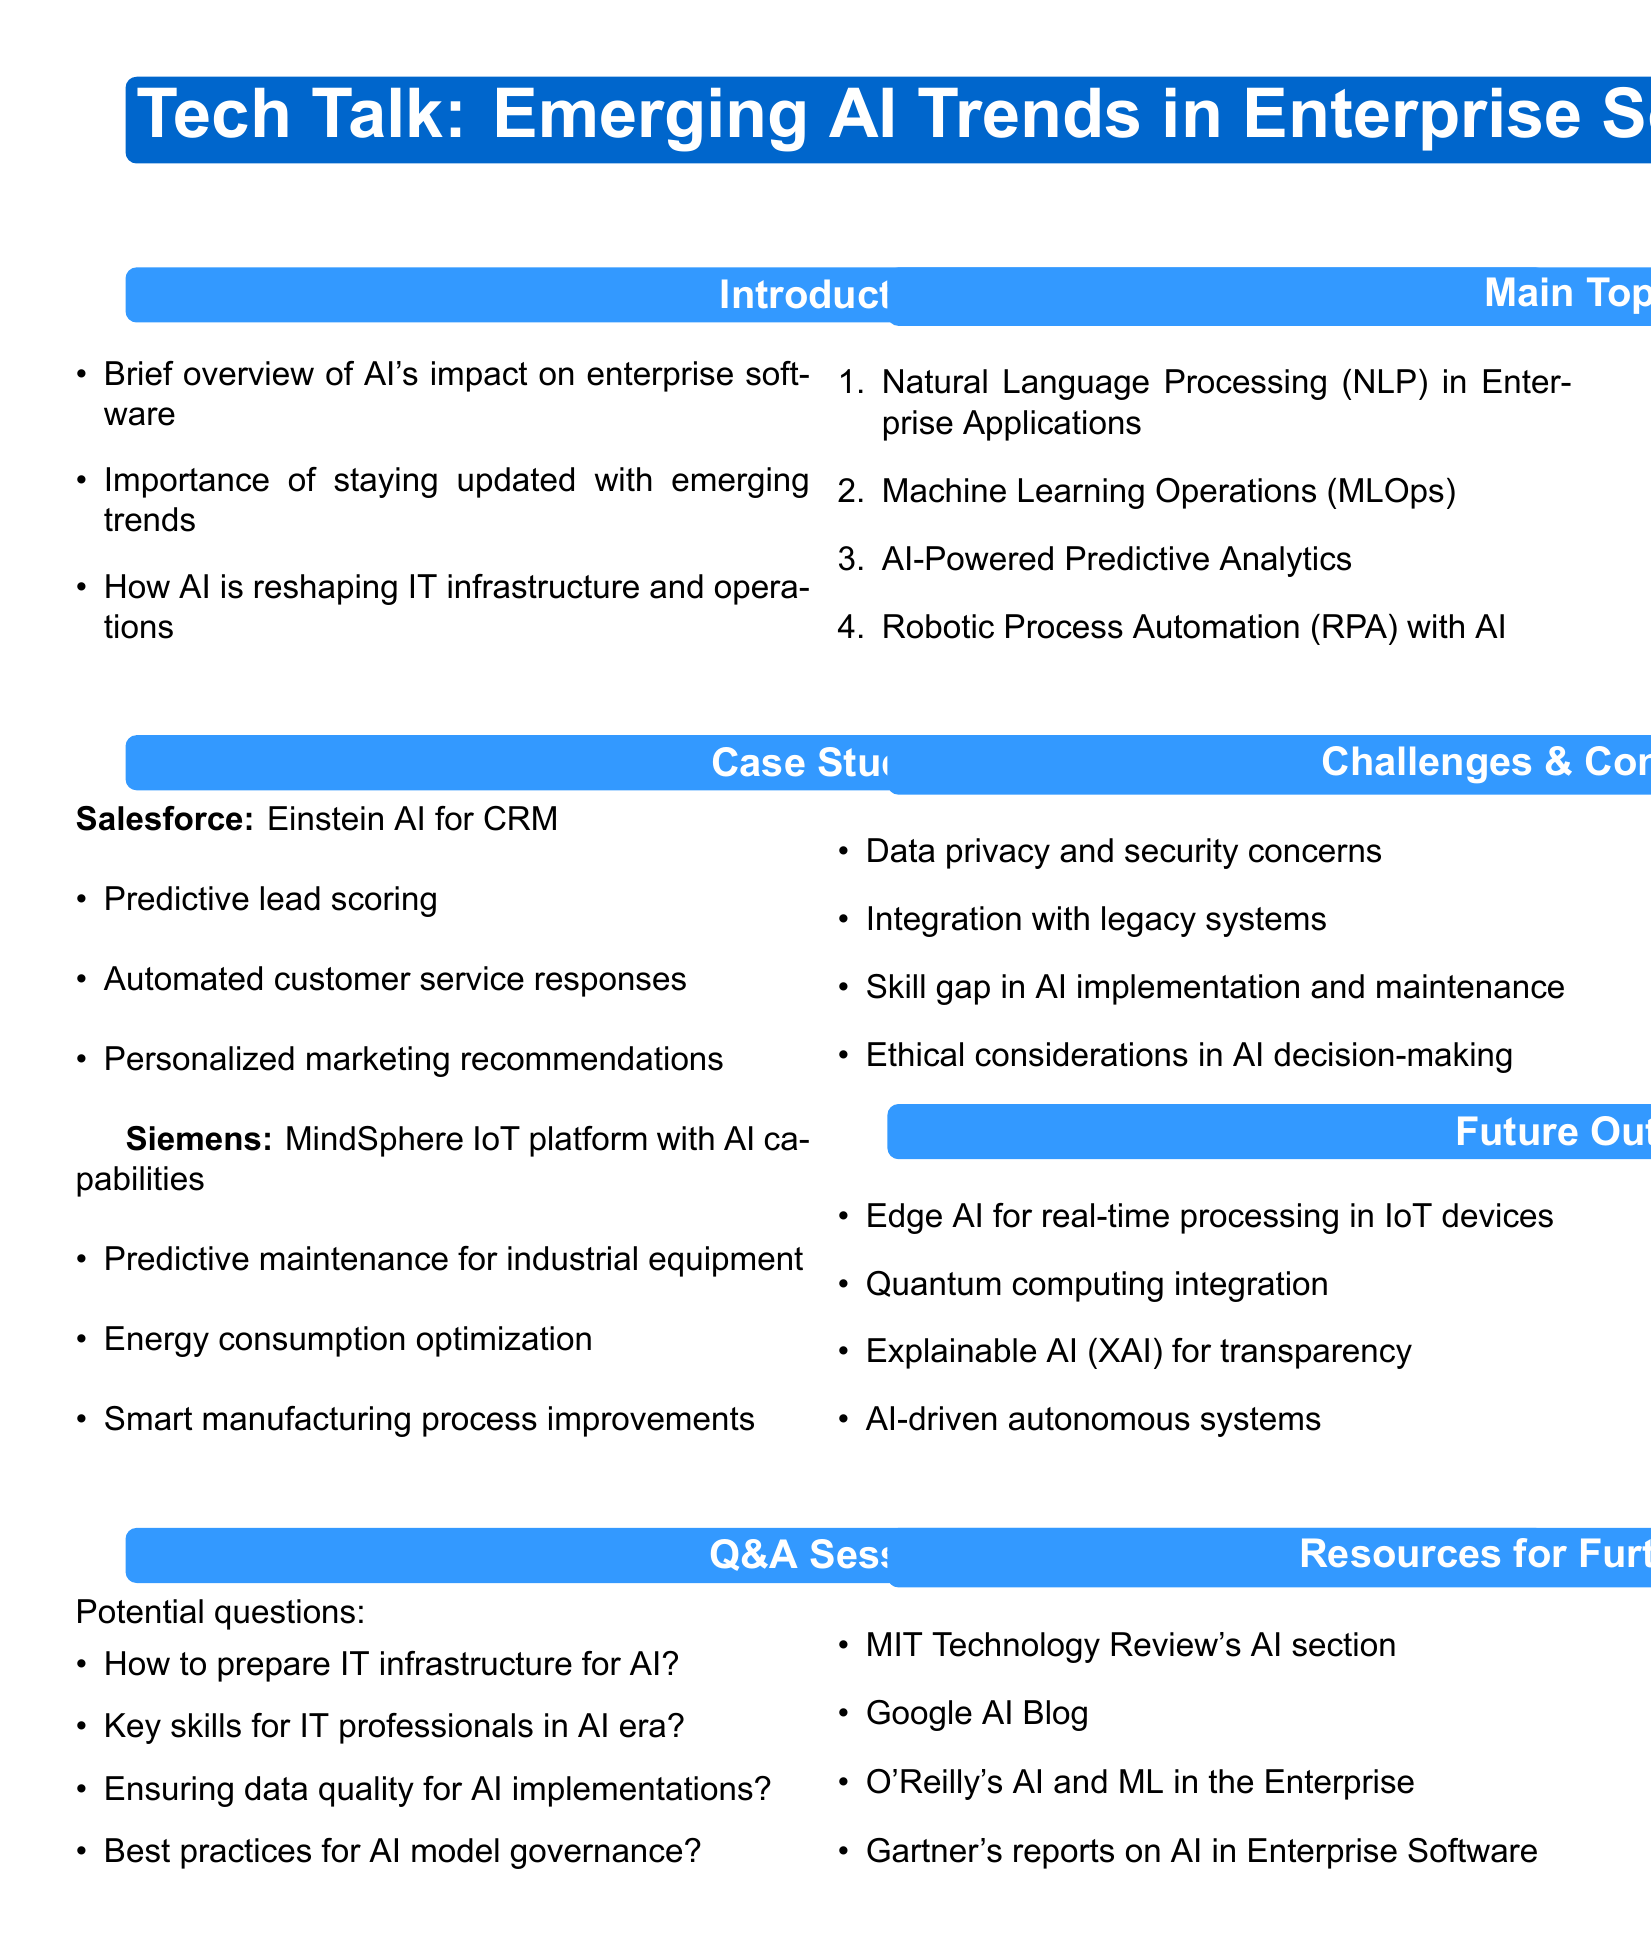What is the title of the tech talk? The title of the tech talk is stated at the beginning of the document.
Answer: Tech Talk: Emerging AI Trends in Enterprise Software What is one benefit of Salesforce's AI implementation? The document lists multiple benefits of Salesforce's AI implementation in the case study section.
Answer: Predictive lead scoring What are the key skills needed for IT professionals in the AI era? The document includes a question in the Q&A session section that addresses the skills needed for IT professionals.
Answer: Key skills for IT professionals in AI era? What is one challenge mentioned regarding AI implementation? The challenges related to AI implementation are listed in the challenges and considerations section of the document.
Answer: Data privacy and security concerns Which company uses MindSphere IoT platform with AI capabilities? The document specifies the company that has implemented the described AI solution in the case studies section.
Answer: Siemens What is listed as a future trend related to AI in the document? The future outlook section lists emerging trends related to AI that the document predicts will impact enterprise software.
Answer: Edge AI for real-time processing in IoT devices What type of AI technology is used for automated document processing? The subtopic under the Robotic Process Automation section mentions specific AI technologies used in enterprise applications.
Answer: Intelligent document processing How does the document categorize its main topics? The main topics are organized in a specific format for easy understanding in the document.
Answer: Enumerated list What is one resource for further learning mentioned in the document? The document lists resources that readers can use for further information on the topic.
Answer: MIT Technology Review's AI section 